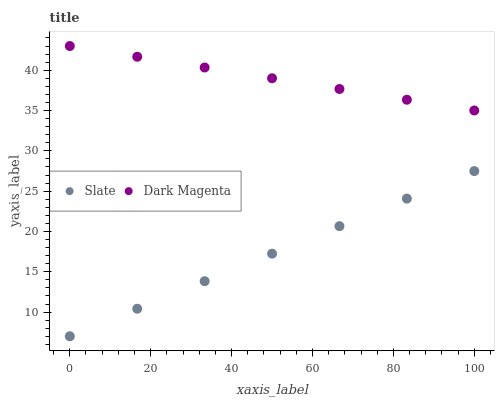Does Slate have the minimum area under the curve?
Answer yes or no. Yes. Does Dark Magenta have the maximum area under the curve?
Answer yes or no. Yes. Does Dark Magenta have the minimum area under the curve?
Answer yes or no. No. Is Dark Magenta the smoothest?
Answer yes or no. Yes. Is Slate the roughest?
Answer yes or no. Yes. Is Dark Magenta the roughest?
Answer yes or no. No. Does Slate have the lowest value?
Answer yes or no. Yes. Does Dark Magenta have the lowest value?
Answer yes or no. No. Does Dark Magenta have the highest value?
Answer yes or no. Yes. Is Slate less than Dark Magenta?
Answer yes or no. Yes. Is Dark Magenta greater than Slate?
Answer yes or no. Yes. Does Slate intersect Dark Magenta?
Answer yes or no. No. 